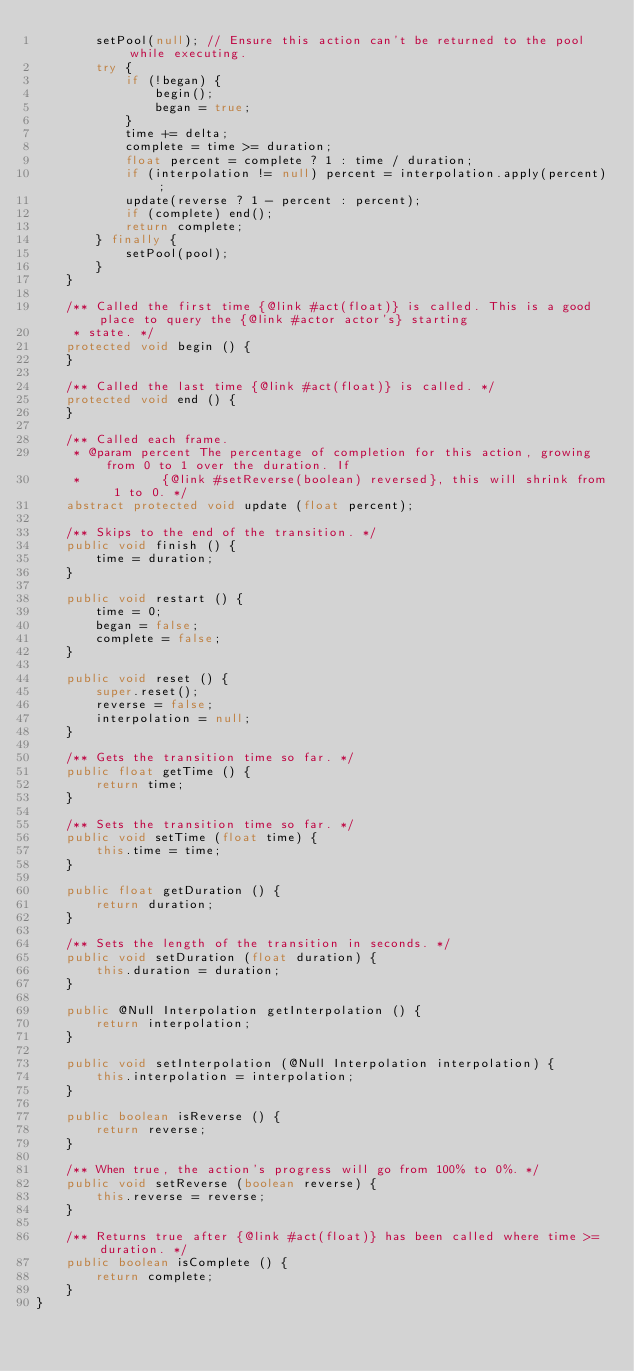Convert code to text. <code><loc_0><loc_0><loc_500><loc_500><_Java_>		setPool(null); // Ensure this action can't be returned to the pool while executing.
		try {
			if (!began) {
				begin();
				began = true;
			}
			time += delta;
			complete = time >= duration;
			float percent = complete ? 1 : time / duration;
			if (interpolation != null) percent = interpolation.apply(percent);
			update(reverse ? 1 - percent : percent);
			if (complete) end();
			return complete;
		} finally {
			setPool(pool);
		}
	}

	/** Called the first time {@link #act(float)} is called. This is a good place to query the {@link #actor actor's} starting
	 * state. */
	protected void begin () {
	}

	/** Called the last time {@link #act(float)} is called. */
	protected void end () {
	}

	/** Called each frame.
	 * @param percent The percentage of completion for this action, growing from 0 to 1 over the duration. If
	 *           {@link #setReverse(boolean) reversed}, this will shrink from 1 to 0. */
	abstract protected void update (float percent);

	/** Skips to the end of the transition. */
	public void finish () {
		time = duration;
	}

	public void restart () {
		time = 0;
		began = false;
		complete = false;
	}

	public void reset () {
		super.reset();
		reverse = false;
		interpolation = null;
	}

	/** Gets the transition time so far. */
	public float getTime () {
		return time;
	}

	/** Sets the transition time so far. */
	public void setTime (float time) {
		this.time = time;
	}

	public float getDuration () {
		return duration;
	}

	/** Sets the length of the transition in seconds. */
	public void setDuration (float duration) {
		this.duration = duration;
	}

	public @Null Interpolation getInterpolation () {
		return interpolation;
	}

	public void setInterpolation (@Null Interpolation interpolation) {
		this.interpolation = interpolation;
	}

	public boolean isReverse () {
		return reverse;
	}

	/** When true, the action's progress will go from 100% to 0%. */
	public void setReverse (boolean reverse) {
		this.reverse = reverse;
	}

	/** Returns true after {@link #act(float)} has been called where time >= duration. */
	public boolean isComplete () {
		return complete;
	}
}
</code> 